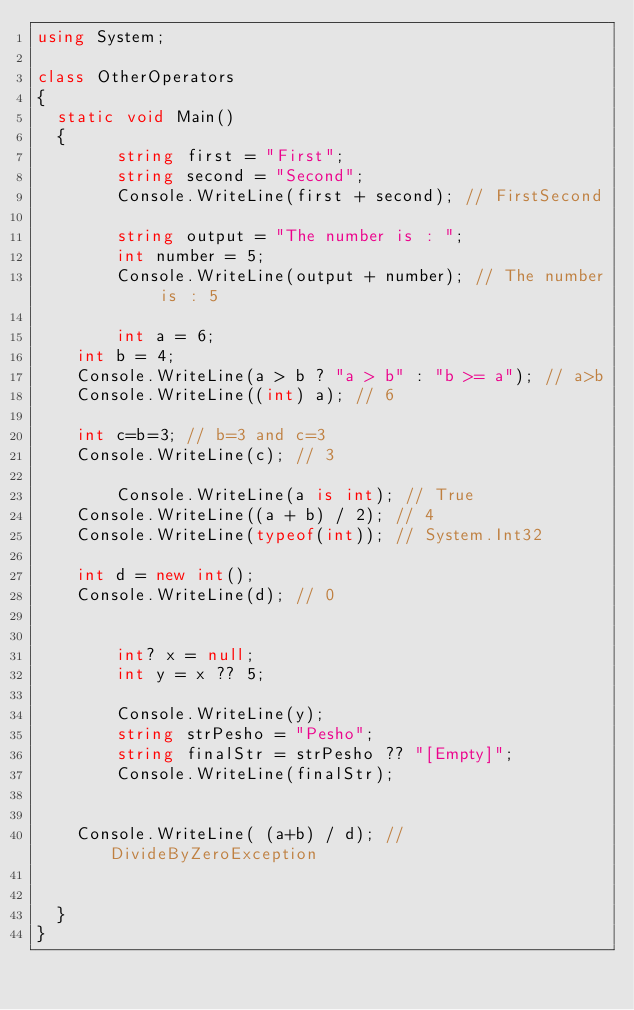<code> <loc_0><loc_0><loc_500><loc_500><_C#_>using System;

class OtherOperators
{
	static void Main()
	{
        string first = "First";
        string second = "Second";
        Console.WriteLine(first + second); // FirstSecond
        
        string output = "The number is : ";
        int number = 5;
        Console.WriteLine(output + number); // The number is : 5

        int a = 6;
		int b = 4;
		Console.WriteLine(a > b ? "a > b" : "b >= a"); // a>b
		Console.WriteLine((int) a); // 6

		int c=b=3; // b=3 and c=3
		Console.WriteLine(c); // 3
		
        Console.WriteLine(a is int); // True
		Console.WriteLine((a + b) / 2); // 4
		Console.WriteLine(typeof(int)); // System.Int32

		int d = new int();
		Console.WriteLine(d); // 0


        int? x = null;
        int y = x ?? 5;

        Console.WriteLine(y);
        string strPesho = "Pesho";
        string finalStr = strPesho ?? "[Empty]";
        Console.WriteLine(finalStr);


		Console.WriteLine( (a+b) / d); // DivideByZeroException


	}
}
</code> 